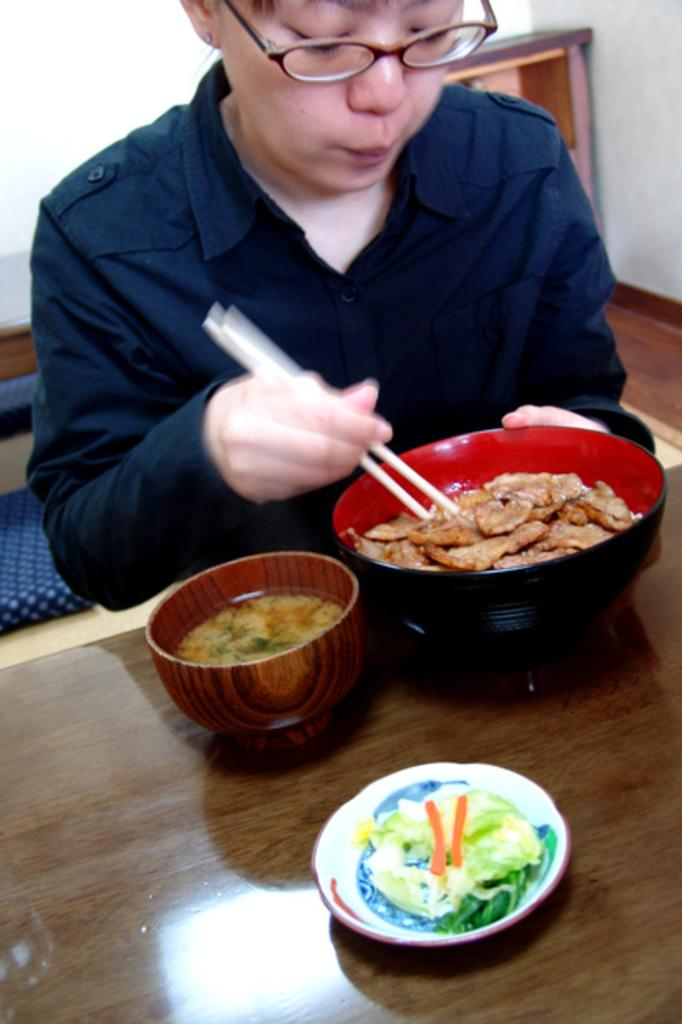Who is the person in the image? There is a man in the image. What is the man doing in the image? The man is sitting on a dining table and eating food from a bowl. What utensil is the man using to eat? The man is using chopsticks to eat. Are there any other items on the table? Yes, there are other bowls on the table. What type of apparel is the man wearing in the image? The provided facts do not mention the man's apparel, so we cannot determine what type of clothing he is wearing. Is there a tub visible in the image? No, there is no tub present in the image. 